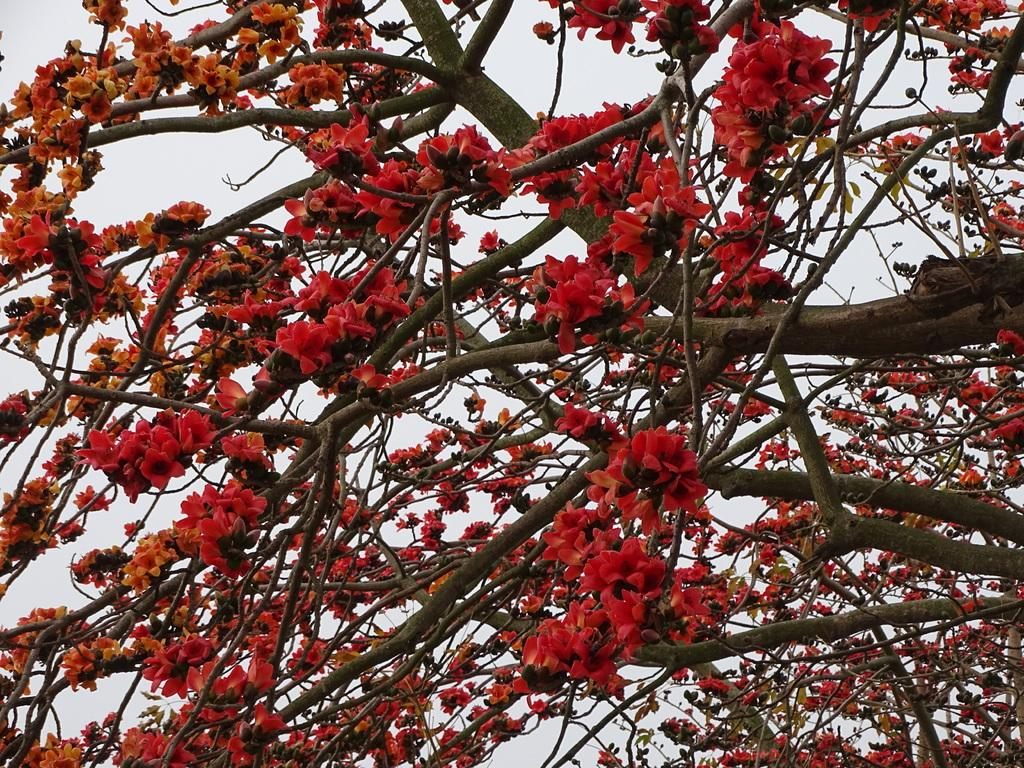What type of vegetation can be seen in the image? There are branches of trees in the image. What color are the flowers in the image? The flowers in the image are red-colored. What is the income of the person holding the celery in the image? There is no person holding celery in the image, and therefore no income can be determined. 